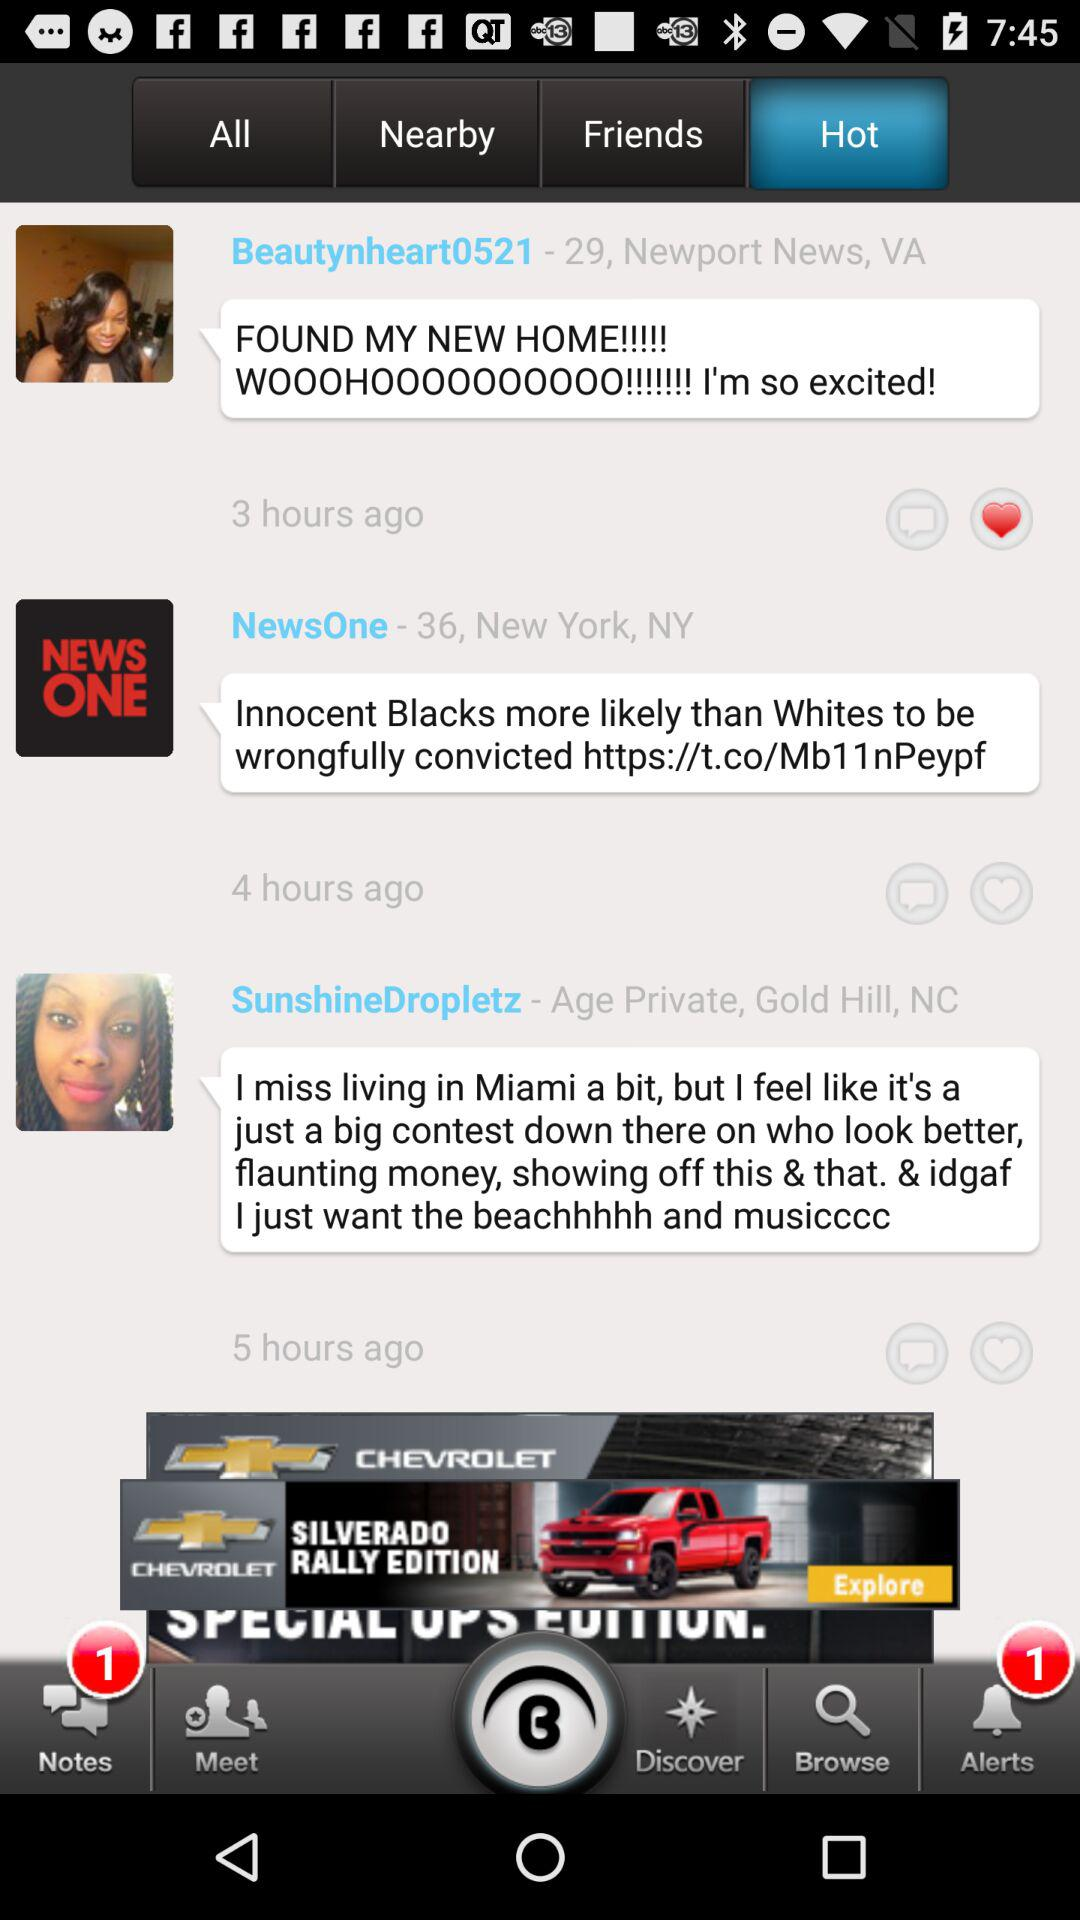How many notes are unread? There is 1 note unread. 